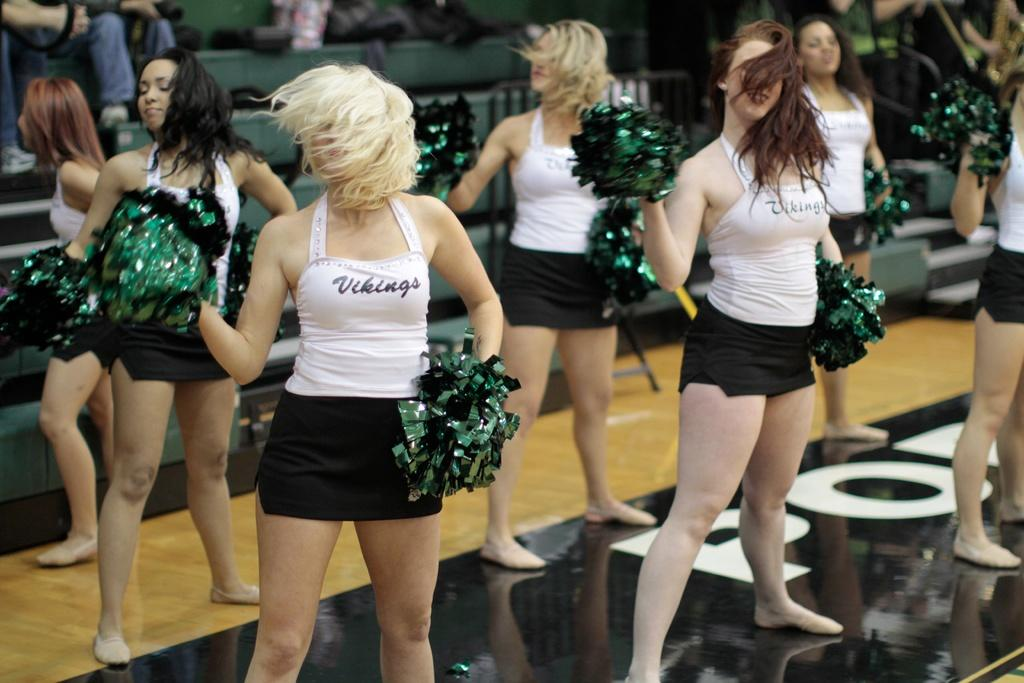<image>
Offer a succinct explanation of the picture presented. Cheerleaders for the vikings perform on the court. 